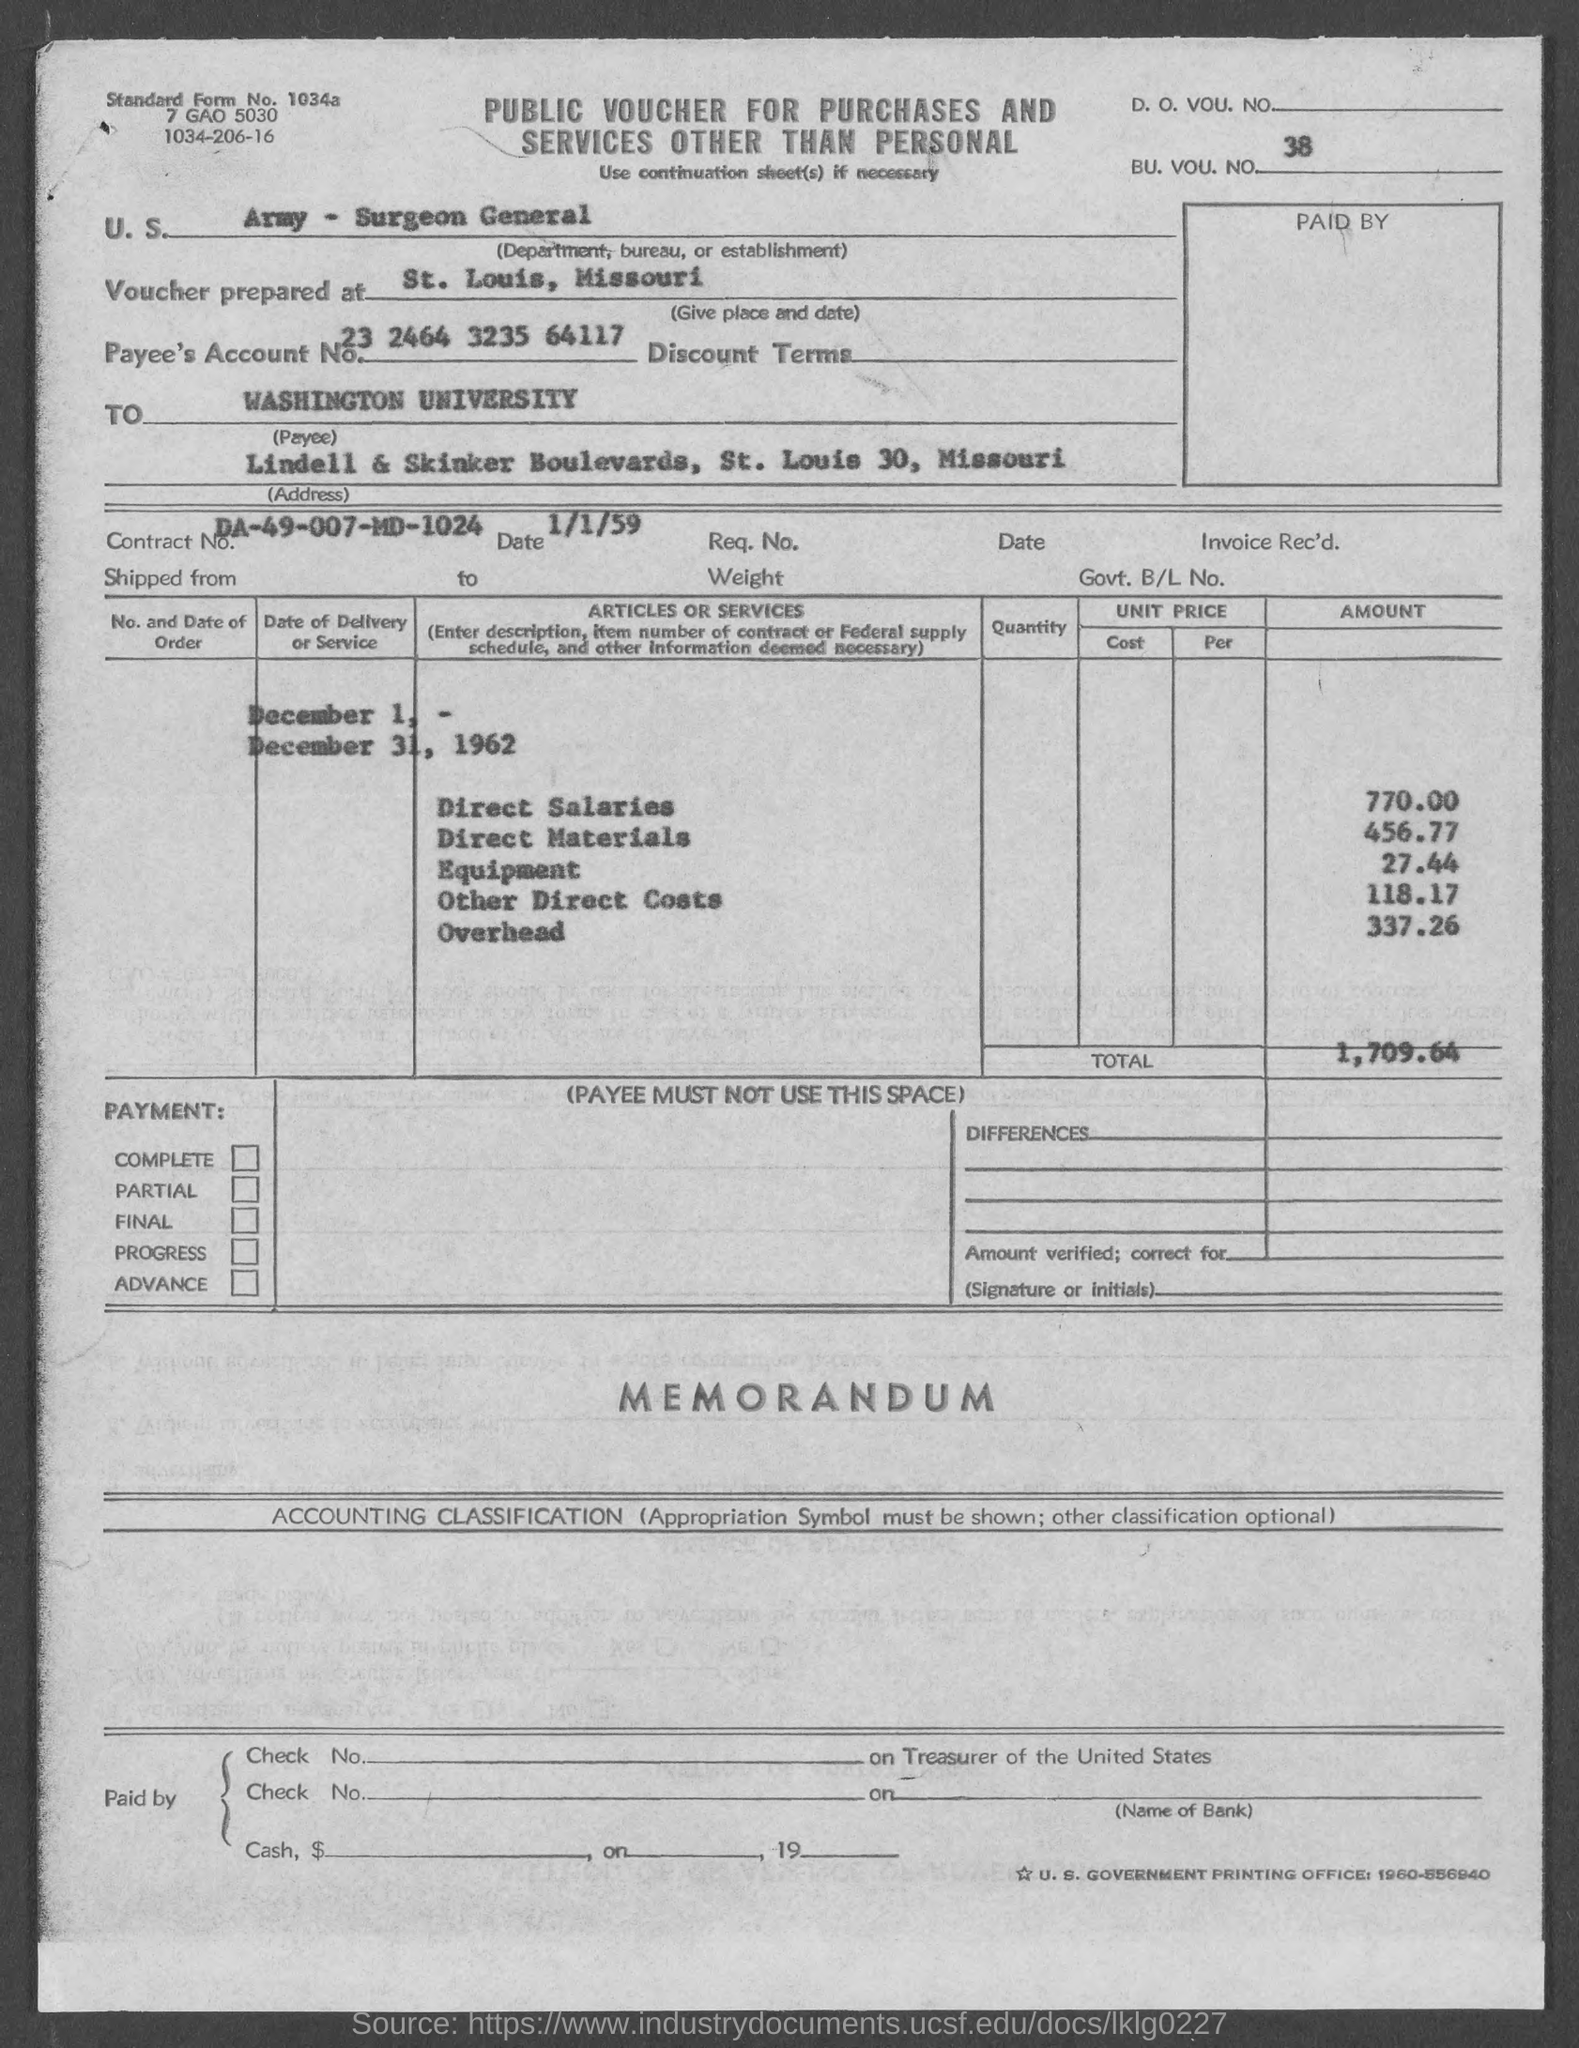Indicate a few pertinent items in this graphic. The standard form number is 1034a... The total is 1,709.64, including any decimals. There are 27 pieces of equipment currently in stock. Additionally, there are 44 pieces of equipment on order. The amount of overhead is 337 and the second part of the sentence is 26 and something else that I cannot see. The payee's account number is 23 2464 3235 64117. 